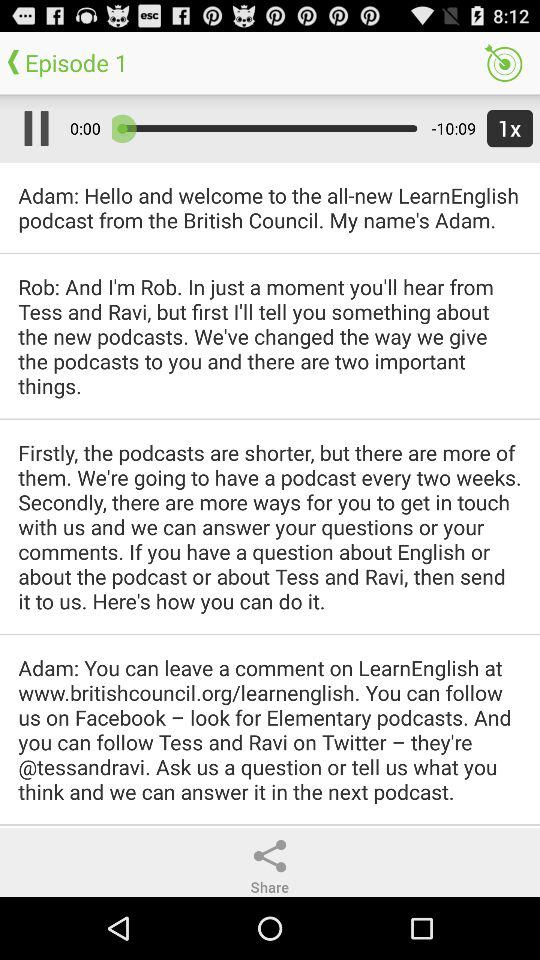What is the maximum duration of "Episode 1"? The maximum duration is 10 minutes 9 seconds. 